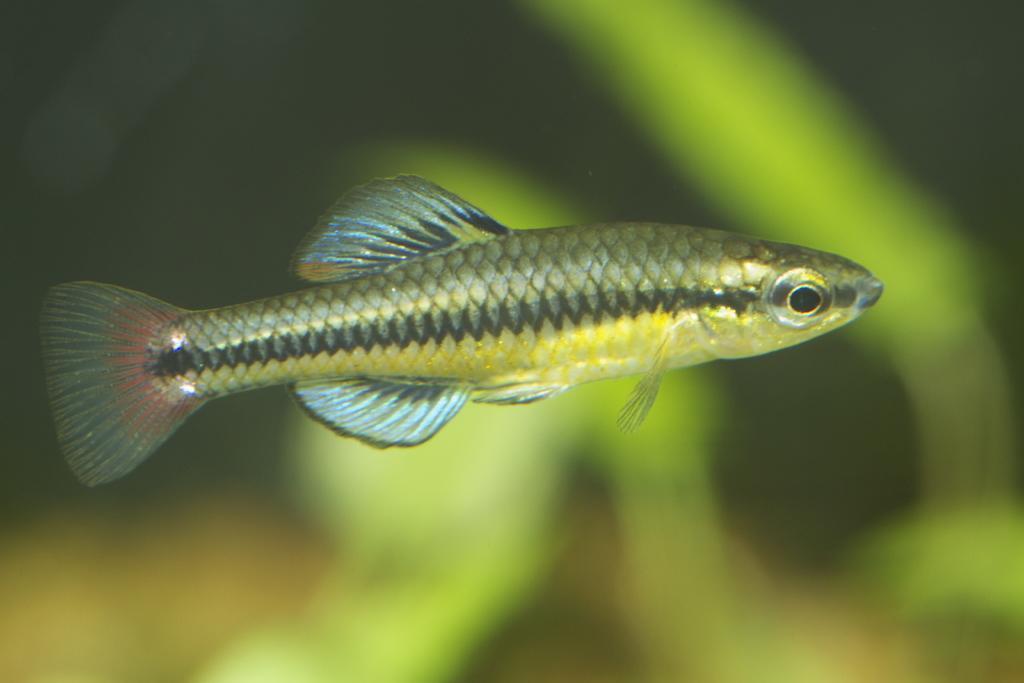How would you summarize this image in a sentence or two? In this image, we can see a fish on the blur background. 